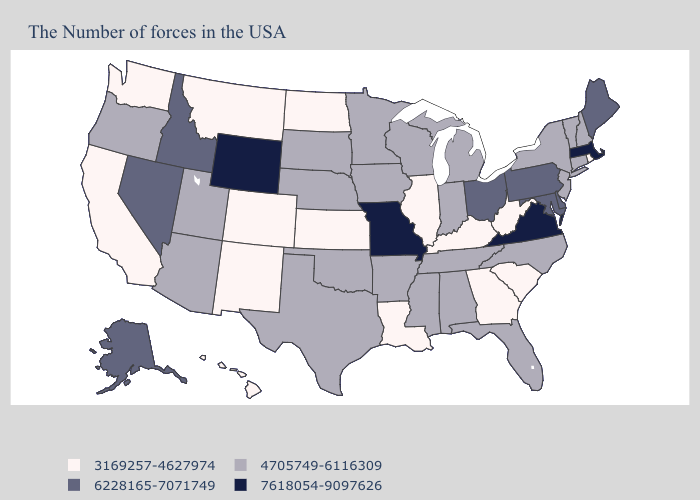Name the states that have a value in the range 6228165-7071749?
Keep it brief. Maine, Delaware, Maryland, Pennsylvania, Ohio, Idaho, Nevada, Alaska. Does Ohio have the same value as Nebraska?
Be succinct. No. Name the states that have a value in the range 3169257-4627974?
Quick response, please. Rhode Island, South Carolina, West Virginia, Georgia, Kentucky, Illinois, Louisiana, Kansas, North Dakota, Colorado, New Mexico, Montana, California, Washington, Hawaii. What is the lowest value in the MidWest?
Concise answer only. 3169257-4627974. Which states have the highest value in the USA?
Answer briefly. Massachusetts, Virginia, Missouri, Wyoming. Name the states that have a value in the range 3169257-4627974?
Write a very short answer. Rhode Island, South Carolina, West Virginia, Georgia, Kentucky, Illinois, Louisiana, Kansas, North Dakota, Colorado, New Mexico, Montana, California, Washington, Hawaii. Does the map have missing data?
Keep it brief. No. Does Rhode Island have the lowest value in the Northeast?
Concise answer only. Yes. Is the legend a continuous bar?
Be succinct. No. Does Virginia have the highest value in the USA?
Give a very brief answer. Yes. Name the states that have a value in the range 6228165-7071749?
Quick response, please. Maine, Delaware, Maryland, Pennsylvania, Ohio, Idaho, Nevada, Alaska. Does the map have missing data?
Give a very brief answer. No. Name the states that have a value in the range 4705749-6116309?
Short answer required. New Hampshire, Vermont, Connecticut, New York, New Jersey, North Carolina, Florida, Michigan, Indiana, Alabama, Tennessee, Wisconsin, Mississippi, Arkansas, Minnesota, Iowa, Nebraska, Oklahoma, Texas, South Dakota, Utah, Arizona, Oregon. What is the value of Alaska?
Be succinct. 6228165-7071749. What is the value of Idaho?
Concise answer only. 6228165-7071749. 